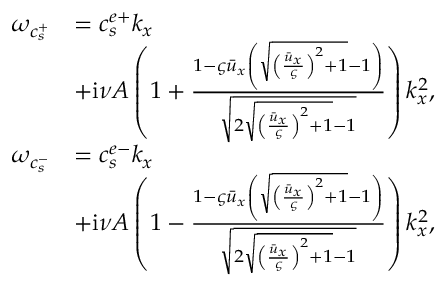Convert formula to latex. <formula><loc_0><loc_0><loc_500><loc_500>\begin{array} { r l } { \omega _ { c _ { s } ^ { + } } } & { = c _ { s } ^ { e + } k _ { x } } \\ & { + i \nu A \left ( 1 + \frac { 1 - \varsigma \bar { u } _ { x } \left ( \sqrt { { \left ( \frac { \bar { u } _ { x } } { \varsigma } \right ) } ^ { 2 } + 1 } - 1 \right ) } { \sqrt { 2 \sqrt { { \left ( \frac { \bar { u } _ { x } } { \varsigma } \right ) } ^ { 2 } + 1 } - 1 } } \right ) k _ { x } ^ { 2 } , } \\ { \omega _ { c _ { s } ^ { - } } } & { = c _ { s } ^ { e - } k _ { x } } \\ & { + i \nu A \left ( 1 - \frac { 1 - \varsigma \bar { u } _ { x } \left ( \sqrt { { \left ( \frac { \bar { u } _ { x } } { \varsigma } \right ) } ^ { 2 } + 1 } - 1 \right ) } { \sqrt { 2 \sqrt { { \left ( \frac { \bar { u } _ { x } } { \varsigma } \right ) } ^ { 2 } + 1 } - 1 } } \right ) k _ { x } ^ { 2 } , } \end{array}</formula> 